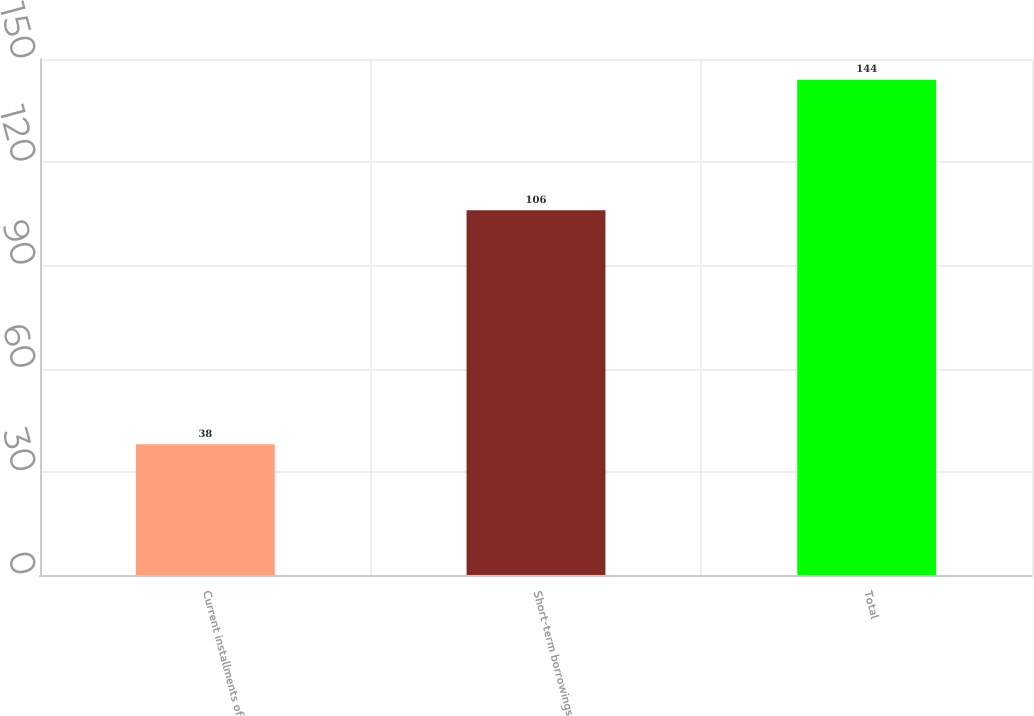<chart> <loc_0><loc_0><loc_500><loc_500><bar_chart><fcel>Current installments of<fcel>Short-term borrowings<fcel>Total<nl><fcel>38<fcel>106<fcel>144<nl></chart> 